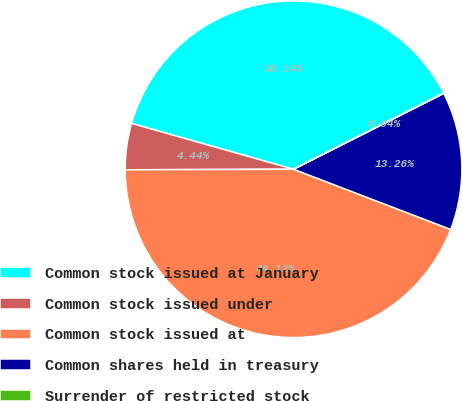Convert chart to OTSL. <chart><loc_0><loc_0><loc_500><loc_500><pie_chart><fcel>Common stock issued at January<fcel>Common stock issued under<fcel>Common stock issued at<fcel>Common shares held in treasury<fcel>Surrender of restricted stock<nl><fcel>38.14%<fcel>4.44%<fcel>44.12%<fcel>13.26%<fcel>0.04%<nl></chart> 